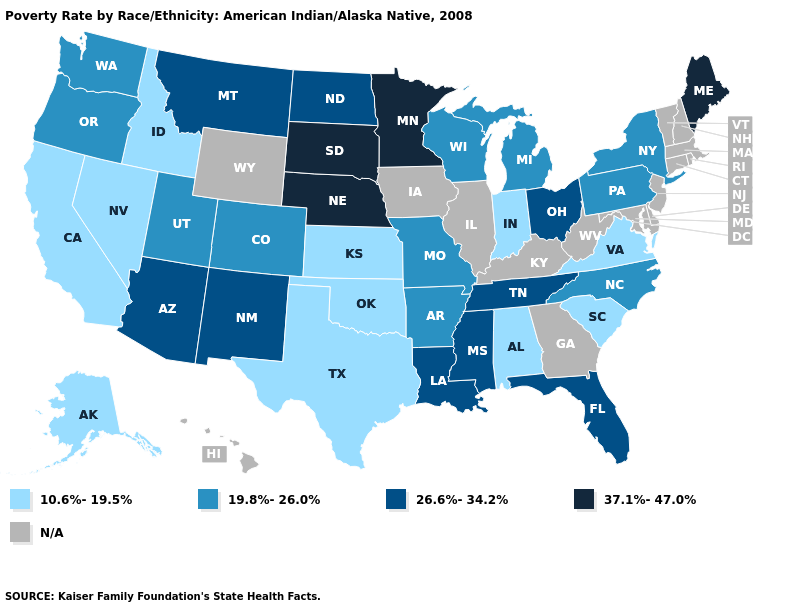Among the states that border Minnesota , which have the highest value?
Concise answer only. South Dakota. Which states have the lowest value in the MidWest?
Give a very brief answer. Indiana, Kansas. What is the value of Arkansas?
Answer briefly. 19.8%-26.0%. What is the value of South Carolina?
Write a very short answer. 10.6%-19.5%. Does Michigan have the highest value in the USA?
Be succinct. No. What is the value of Texas?
Concise answer only. 10.6%-19.5%. Name the states that have a value in the range 37.1%-47.0%?
Quick response, please. Maine, Minnesota, Nebraska, South Dakota. Does Indiana have the lowest value in the USA?
Concise answer only. Yes. What is the highest value in the MidWest ?
Give a very brief answer. 37.1%-47.0%. What is the value of Louisiana?
Write a very short answer. 26.6%-34.2%. Name the states that have a value in the range 26.6%-34.2%?
Concise answer only. Arizona, Florida, Louisiana, Mississippi, Montana, New Mexico, North Dakota, Ohio, Tennessee. What is the value of Montana?
Short answer required. 26.6%-34.2%. Which states hav the highest value in the MidWest?
Answer briefly. Minnesota, Nebraska, South Dakota. What is the highest value in states that border Pennsylvania?
Short answer required. 26.6%-34.2%. 